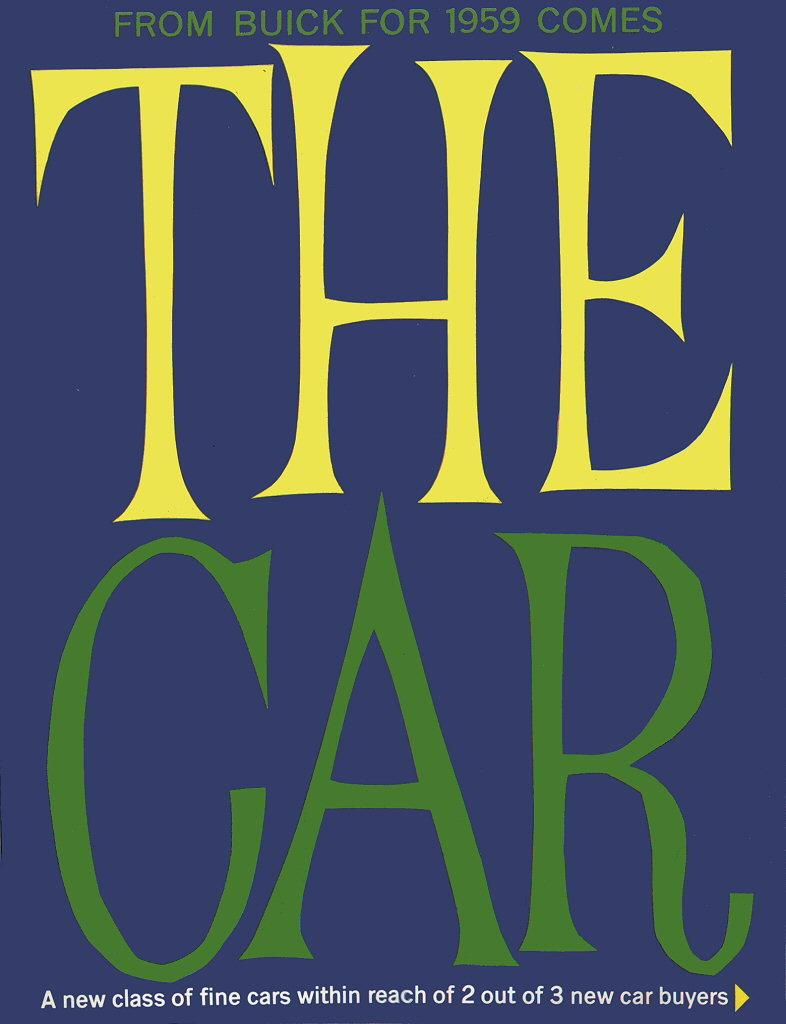<image>
Present a compact description of the photo's key features. blue background with large the car on it in yellow and green letters 